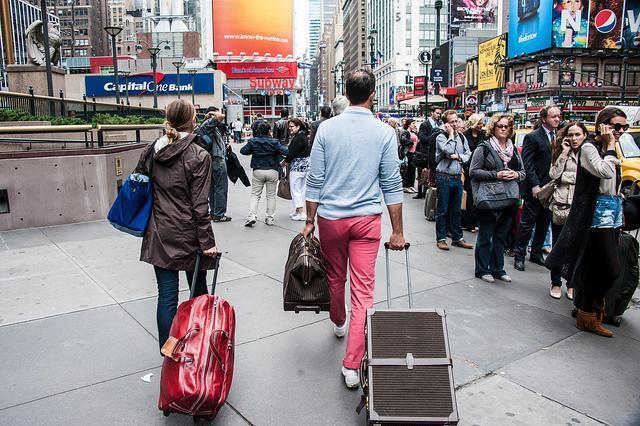How many handbags are there?
Give a very brief answer. 2. How many people are there?
Give a very brief answer. 8. How many suitcases are visible?
Give a very brief answer. 2. How many levels does the bus have?
Give a very brief answer. 0. 